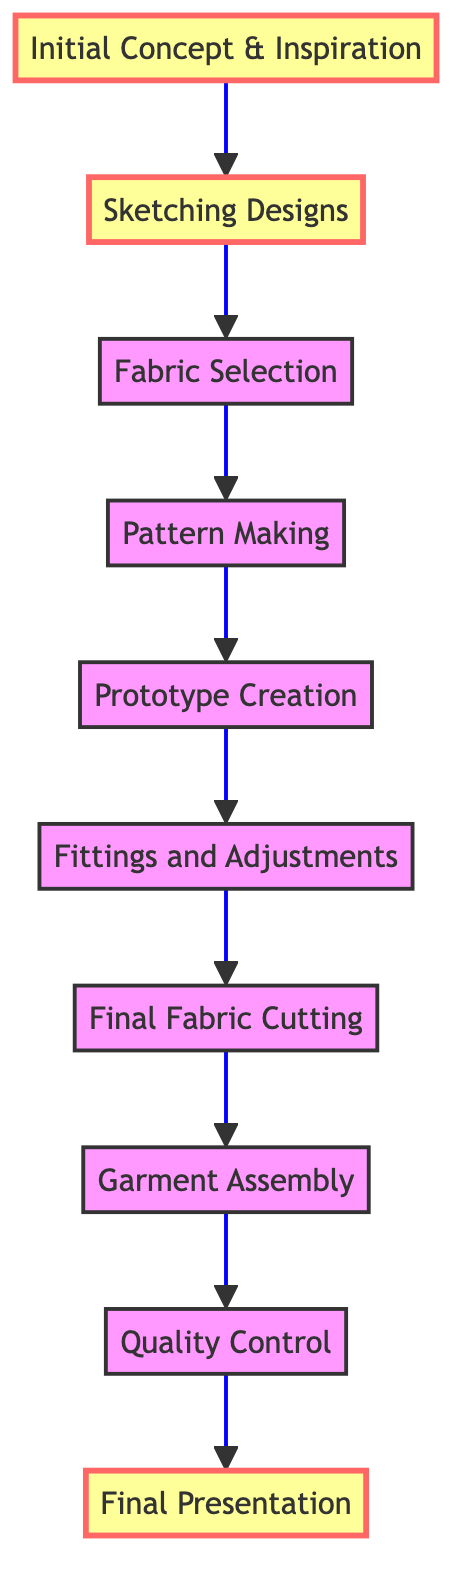What's the first step in the garment journey? The diagram starts with "Initial Concept & Inspiration," indicating that this is the first step in the garment creation process.
Answer: Initial Concept & Inspiration How many steps are there from sketch to finished product? Counting all the nodes in the diagram from "Initial Concept & Inspiration" to "Final Presentation," there are ten distinct steps.
Answer: Ten What comes after fabric selection? Following "Fabric Selection" in the diagram is "Pattern Making," indicating the next step in the garment creation process.
Answer: Pattern Making Which step involves creating a sample garment? The step "Prototype Creation" specifically mentions the construction of a sample garment to test design and fit.
Answer: Prototype Creation What is the last step before the final presentation? The diagram shows "Quality Control" as the last step leading up to the "Final Presentation," verifying the finished product's quality.
Answer: Quality Control Which design process step shows a reliance on editor feedback? The step "Sketching Designs" reflects a connection to early career mentorship from fashion editors, highlighting the influence of editorial feedback in the design process.
Answer: Sketching Designs How many fittings are conducted in the adjustments phase? The diagram does not specify an exact number of fittings, but it mentions multiple fitting sessions, signifying more than one.
Answer: Multiple What key influence is present throughout the garment journey? The consistent mention of editorial advice or mentorship indicates that professional guidance is a key influence at various stages of the process.
Answer: Editorial advice What is the purpose of the "Final Fabric Cutting" step? This step is focused on cutting the final fabric pieces accurately based on the adjusted patterns to ensure proper garment assembly.
Answer: Cut final fabric pieces Which step emphasizes quality craftsmanship in assembly? "Garment Assembly" highlights the importance of sewing fabric pieces together with attention to detail, indicating a focus on quality craftsmanship.
Answer: Garment Assembly 